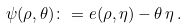Convert formula to latex. <formula><loc_0><loc_0><loc_500><loc_500>\psi ( \rho , \theta ) \colon = e ( \rho , \eta ) - \theta \, \eta \, .</formula> 